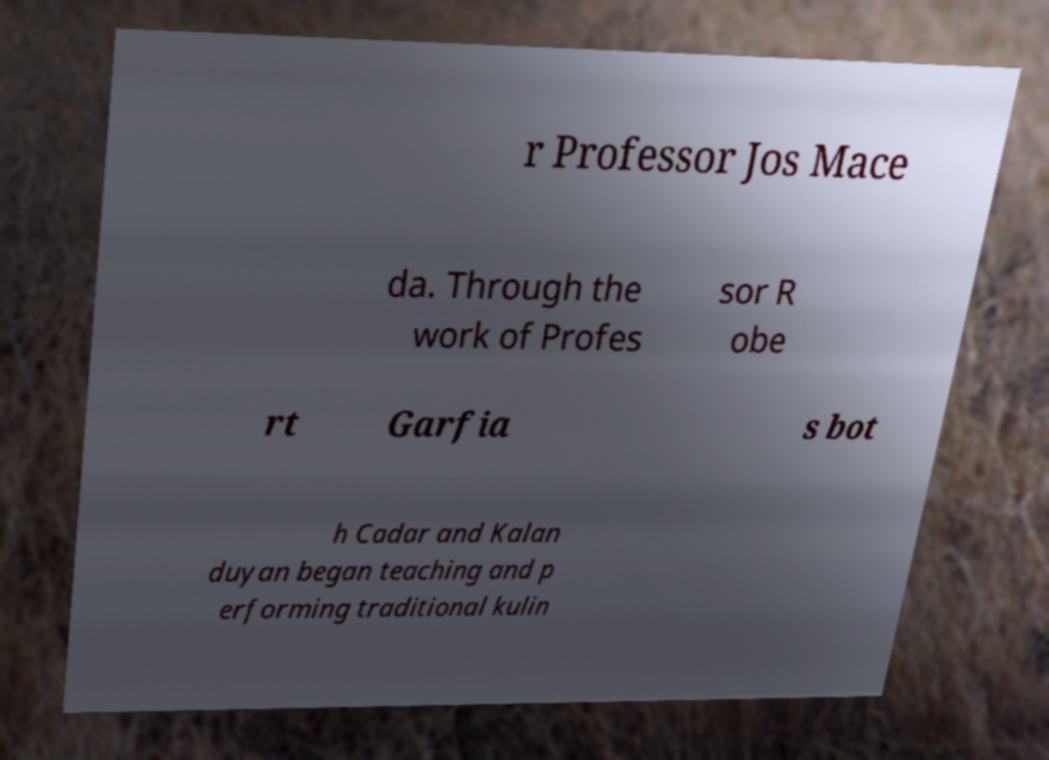What messages or text are displayed in this image? I need them in a readable, typed format. r Professor Jos Mace da. Through the work of Profes sor R obe rt Garfia s bot h Cadar and Kalan duyan began teaching and p erforming traditional kulin 